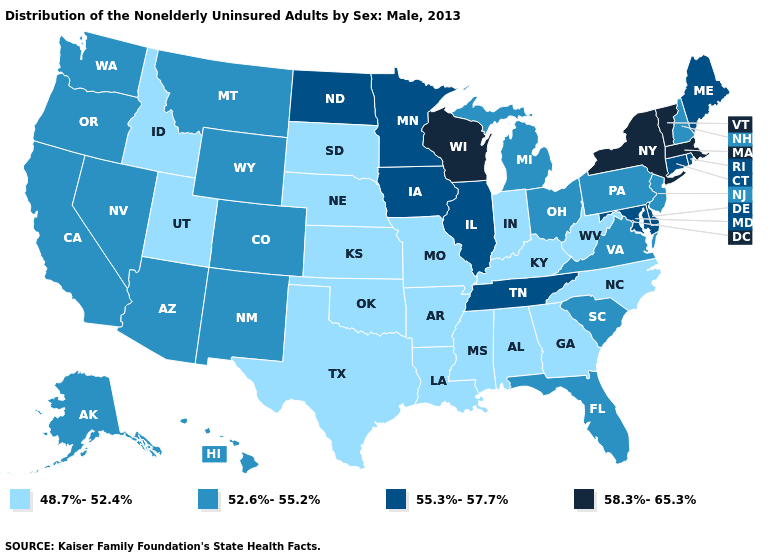Does the first symbol in the legend represent the smallest category?
Write a very short answer. Yes. What is the highest value in states that border Alabama?
Be succinct. 55.3%-57.7%. What is the highest value in the Northeast ?
Concise answer only. 58.3%-65.3%. What is the value of New Jersey?
Answer briefly. 52.6%-55.2%. What is the value of Oklahoma?
Keep it brief. 48.7%-52.4%. Which states hav the highest value in the West?
Answer briefly. Alaska, Arizona, California, Colorado, Hawaii, Montana, Nevada, New Mexico, Oregon, Washington, Wyoming. Does the map have missing data?
Concise answer only. No. What is the value of Idaho?
Concise answer only. 48.7%-52.4%. Among the states that border New York , does Massachusetts have the highest value?
Be succinct. Yes. What is the highest value in the West ?
Concise answer only. 52.6%-55.2%. Name the states that have a value in the range 55.3%-57.7%?
Answer briefly. Connecticut, Delaware, Illinois, Iowa, Maine, Maryland, Minnesota, North Dakota, Rhode Island, Tennessee. Name the states that have a value in the range 58.3%-65.3%?
Answer briefly. Massachusetts, New York, Vermont, Wisconsin. What is the value of Colorado?
Concise answer only. 52.6%-55.2%. What is the highest value in the South ?
Short answer required. 55.3%-57.7%. 